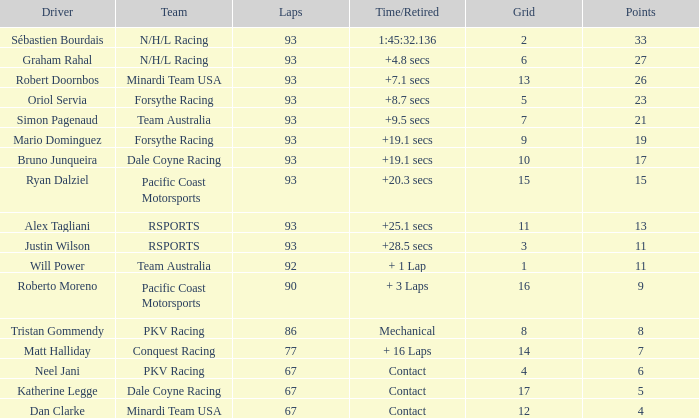What is the layout for the minardi team usa with laps fewer than 90? 12.0. 